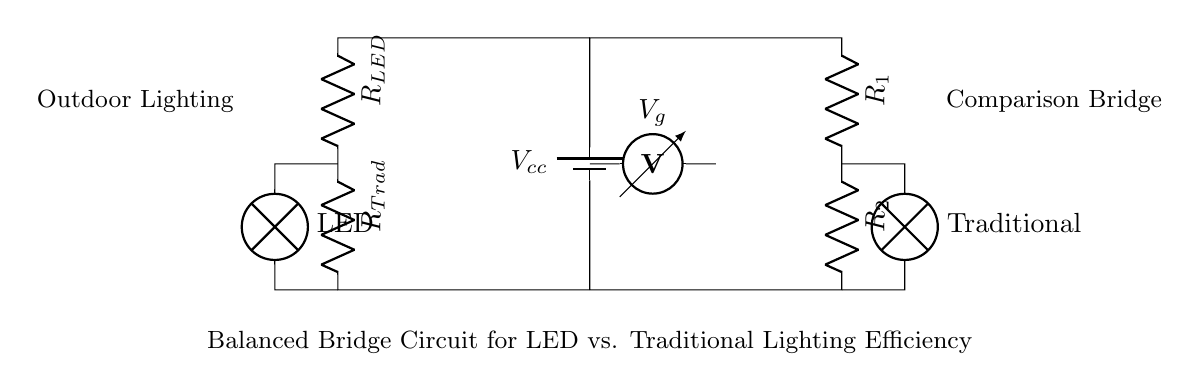What is the type of this circuit? This circuit is a balanced bridge circuit, commonly used for comparing two similar components—in this case, LED and traditional outdoor lighting—by measuring their efficiencies.
Answer: Balanced bridge circuit What do R1 and R2 represent? R1 and R2 are resistors in the circuit. They are used to balance the bridge, allowing for a comparison of the voltage across the LED lamp and the traditional lamp when they are powered.
Answer: Resistors What is indicated by Vg in this circuit? Vg represents the voltage measured across the bridge. It helps in determining whether the bridge is balanced or if one type of lighting is more efficient than the other based on the voltage difference.
Answer: Voltage How many lamps are present in this circuit? There are two lamps shown in the circuit: one for the LED and one for the traditional lighting. These lamps are the components whose efficiencies are being compared.
Answer: Two Which component would likely have a higher efficiency based on this setup? Based on the design of the circuit, it is likely set up to explore which lamp—LED or traditional—has higher efficiency; typically, LEDs are known for their higher efficiency compared to traditional lights.
Answer: LED What does the term balanced imply in this circuit context? "Balanced" implies that the resistances and voltages in both paths of the circuit are equal when measured, indicating equal performance or efficiency between the two types of lighting being tested.
Answer: Equal performance 